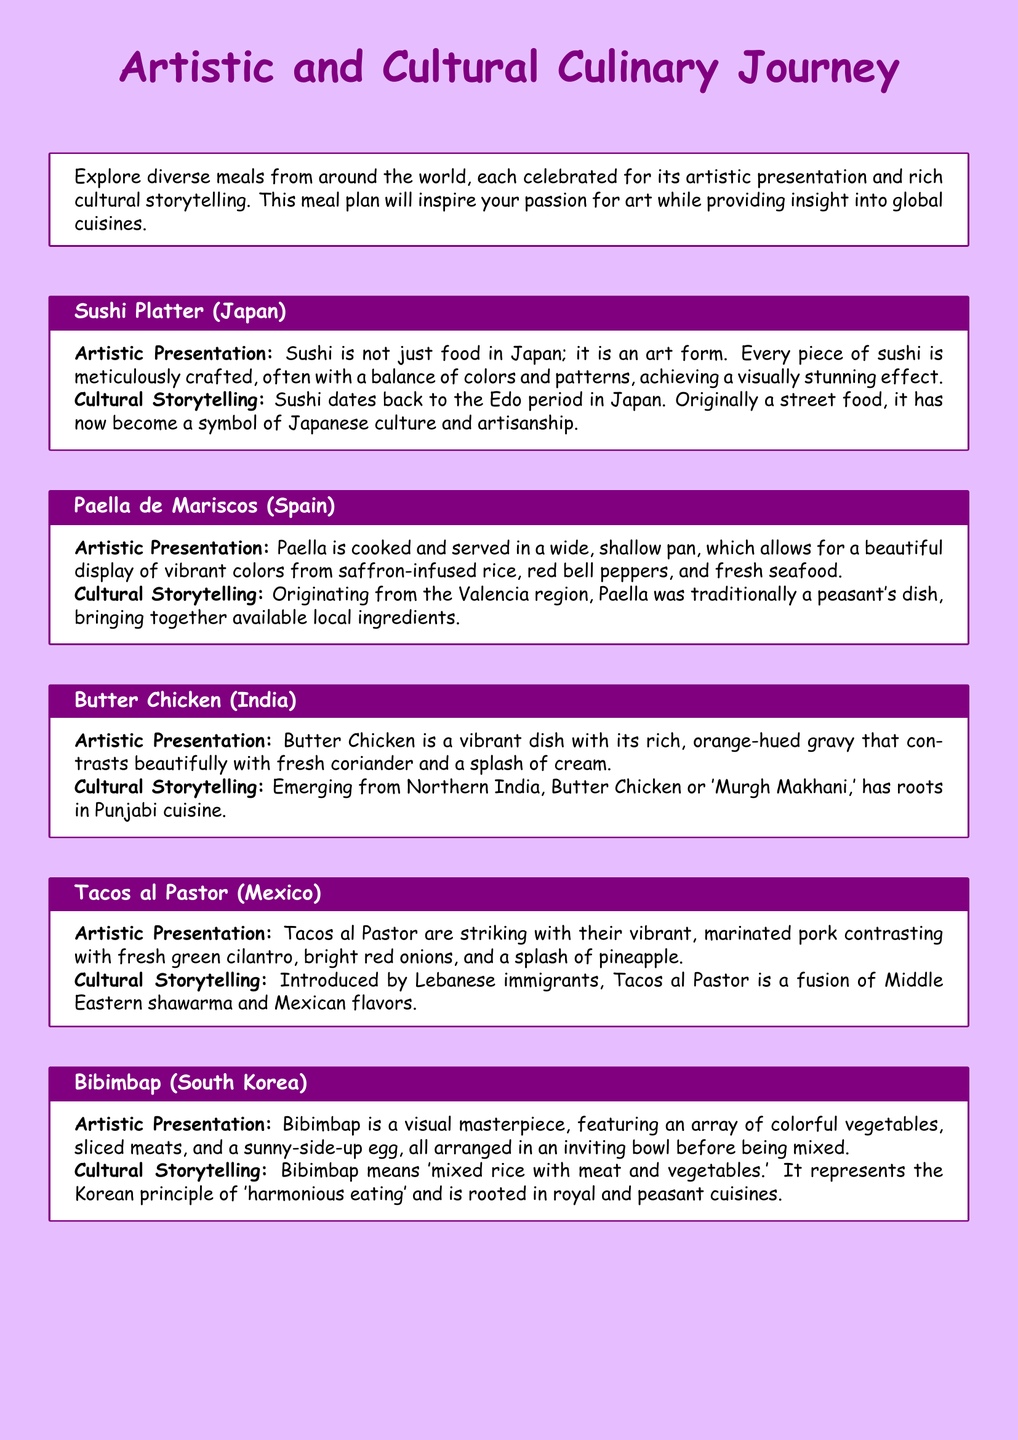What is the first dish mentioned? The first dish in the document is a Sushi Platter, which is prominently featured at the top of the meal plan.
Answer: Sushi Platter How many dishes are included in the meal plan? The document lists a total of five distinct dishes from different cultures around the world.
Answer: Five Which dish originates from India? The meal plan highlights Butter Chicken as the dish that originates from India, listed among the culinary offerings.
Answer: Butter Chicken What is the main color of the Butter Chicken gravy? The description of Butter Chicken states that the gravy is rich and orange-hued, indicating its primary color.
Answer: Orange What cooking method is used for Paella? The document states that Paella is cooked and served in a wide, shallow pan, which describes the cooking method used.
Answer: Shallow pan Which dish features a sunny-side-up egg? Bibimbap is specifically mentioned to include a sunny-side-up egg as part of its artistic presentation.
Answer: Bibimbap What cultural influence contributed to Tacos al Pastor? The document indicates that Tacos al Pastor was introduced by Lebanese immigrants, highlighting its cultural roots.
Answer: Lebanese immigrants What does Bibimbap mean in English? The term 'Bibimbap' translates to 'mixed rice with meat and vegetables,' explaining its name and composition.
Answer: Mixed rice with meat and vegetables 